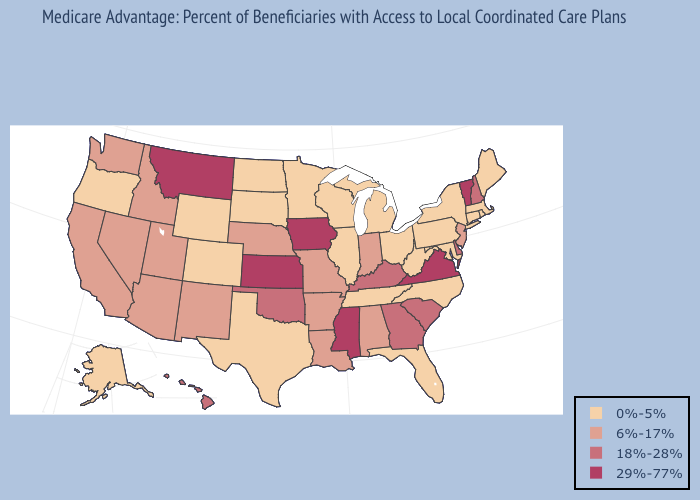Is the legend a continuous bar?
Be succinct. No. Does Nevada have a lower value than New Hampshire?
Concise answer only. Yes. What is the highest value in states that border Illinois?
Short answer required. 29%-77%. Name the states that have a value in the range 18%-28%?
Give a very brief answer. Delaware, Georgia, Hawaii, Kentucky, New Hampshire, Oklahoma, South Carolina. What is the value of Minnesota?
Keep it brief. 0%-5%. What is the lowest value in the USA?
Concise answer only. 0%-5%. Name the states that have a value in the range 6%-17%?
Be succinct. California, Idaho, Indiana, Louisiana, Missouri, Nebraska, New Jersey, New Mexico, Nevada, Utah, Washington, Alabama, Arkansas, Arizona. What is the value of Nebraska?
Answer briefly. 6%-17%. What is the value of Texas?
Answer briefly. 0%-5%. What is the value of Arizona?
Keep it brief. 6%-17%. How many symbols are there in the legend?
Short answer required. 4. Which states hav the highest value in the West?
Write a very short answer. Montana. What is the highest value in states that border Maryland?
Answer briefly. 29%-77%. Name the states that have a value in the range 6%-17%?
Answer briefly. California, Idaho, Indiana, Louisiana, Missouri, Nebraska, New Jersey, New Mexico, Nevada, Utah, Washington, Alabama, Arkansas, Arizona. What is the value of Minnesota?
Be succinct. 0%-5%. 